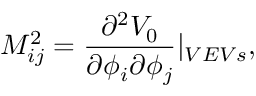Convert formula to latex. <formula><loc_0><loc_0><loc_500><loc_500>M _ { i j } ^ { 2 } = \frac { \partial ^ { 2 } V _ { 0 } } { \partial \phi _ { i } \partial \phi _ { j } } | _ { V E V s } ,</formula> 